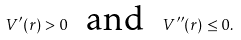<formula> <loc_0><loc_0><loc_500><loc_500>V ^ { \prime } ( r ) > 0 \text { \ and \ } V ^ { \prime \prime } ( r ) \leq 0 .</formula> 